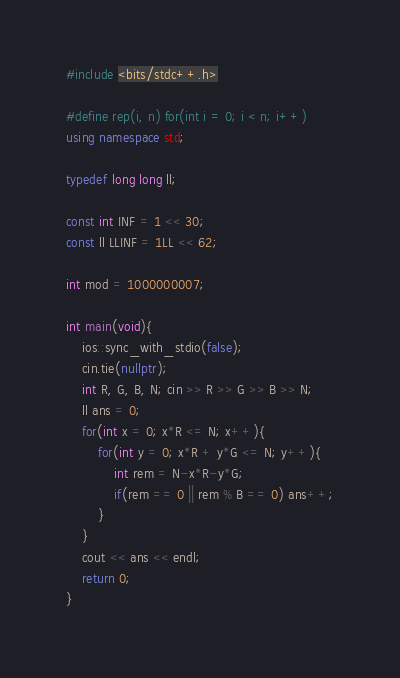<code> <loc_0><loc_0><loc_500><loc_500><_C++_>#include <bits/stdc++.h>

#define rep(i, n) for(int i = 0; i < n; i++)
using namespace std;

typedef long long ll;

const int INF = 1 << 30;
const ll LLINF = 1LL << 62;

int mod = 1000000007;

int main(void){
    ios::sync_with_stdio(false);
    cin.tie(nullptr);
    int R, G, B, N; cin >> R >> G >> B >> N;
    ll ans = 0;
    for(int x = 0; x*R <= N; x++){
        for(int y = 0; x*R + y*G <= N; y++){
            int rem = N-x*R-y*G;
            if(rem == 0 || rem % B == 0) ans++;
        }
    }
    cout << ans << endl;
    return 0;
}</code> 